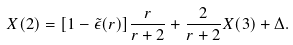Convert formula to latex. <formula><loc_0><loc_0><loc_500><loc_500>X ( 2 ) = [ 1 - \tilde { \epsilon } ( r ) ] \frac { r } { r + 2 } + \frac { 2 } { r + 2 } X ( 3 ) + \Delta .</formula> 